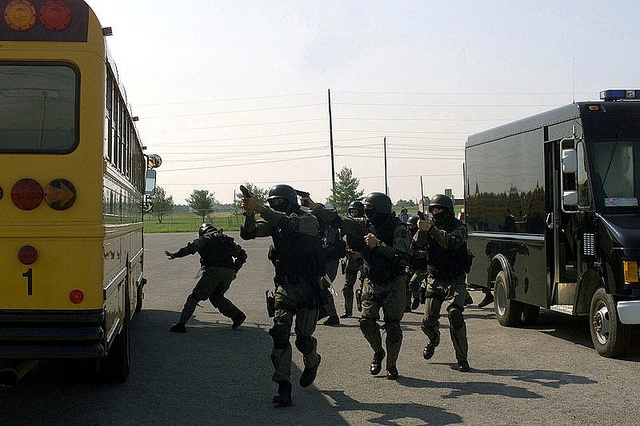Describe the objects in this image and their specific colors. I can see bus in black, olive, gray, and maroon tones, truck in black and gray tones, people in black, gray, darkgray, and darkgreen tones, people in black, gray, and darkgray tones, and people in black, gray, and darkgray tones in this image. 